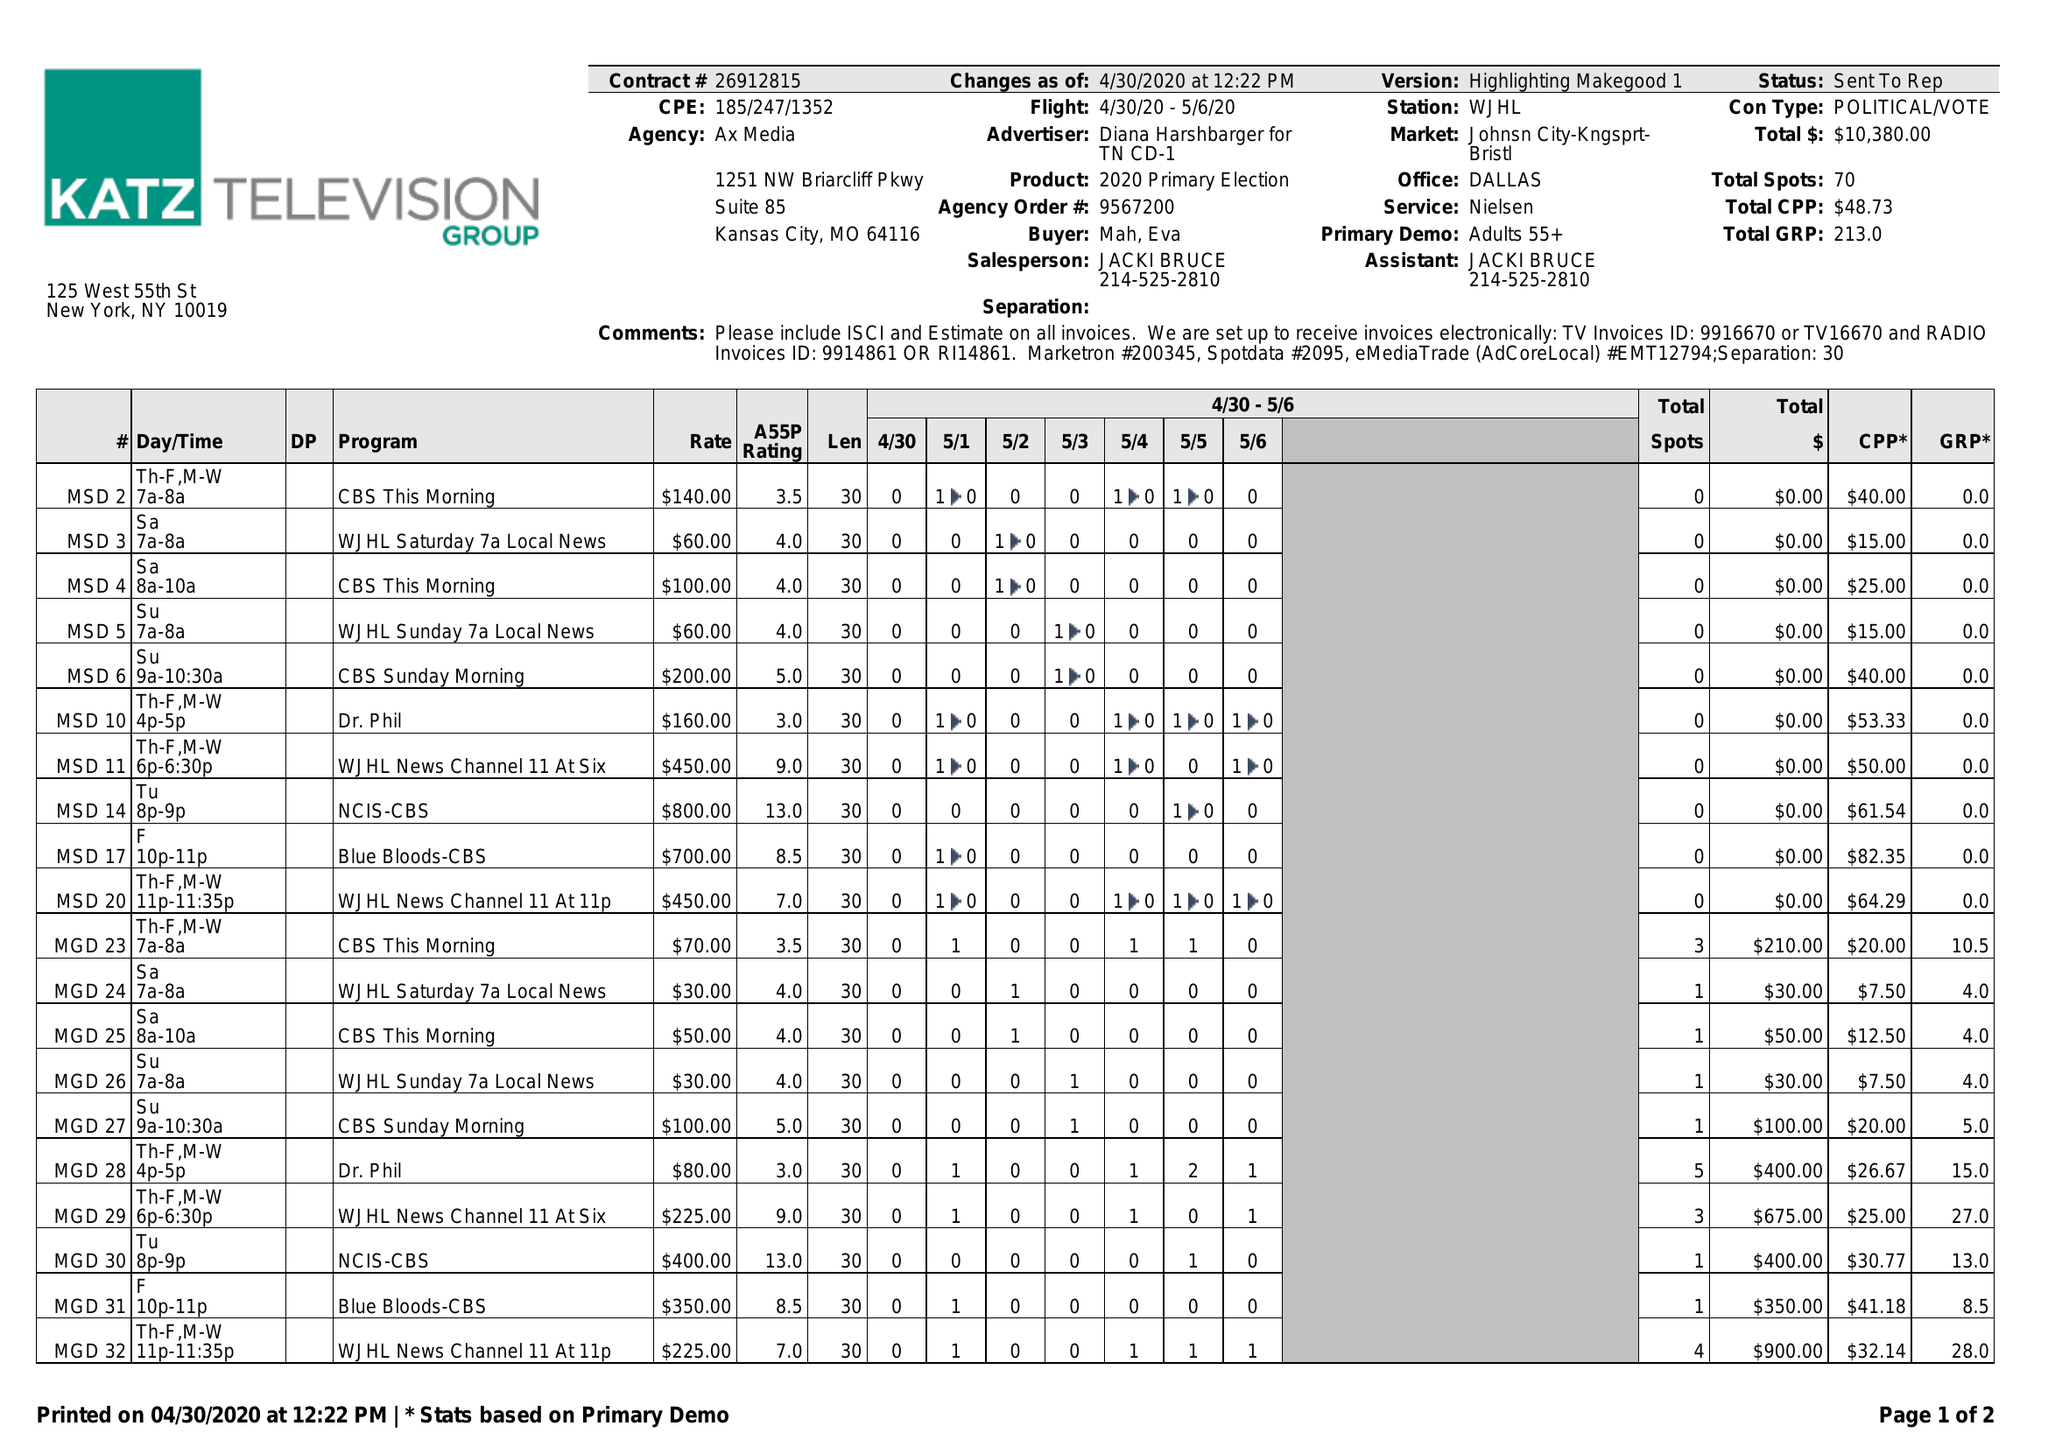What is the value for the flight_to?
Answer the question using a single word or phrase. 05/06/20 